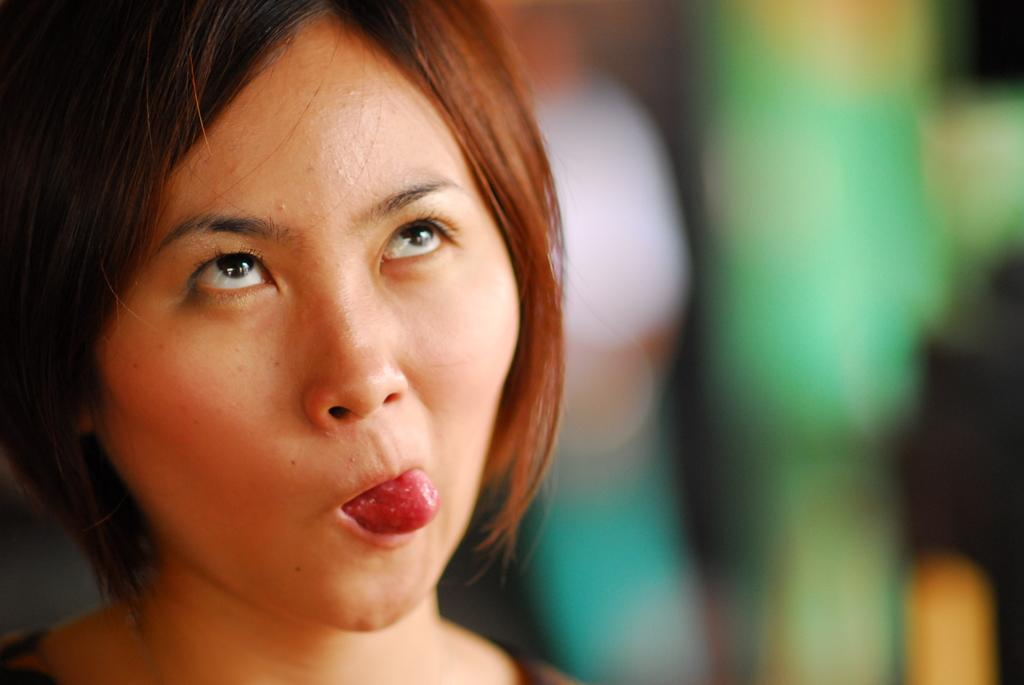Who is the main subject in the image? There is a woman in the image. What is the woman doing in the image? The woman is looking upwards. Can you describe the background of the image? The background of the image is blurred. What type of chain is hanging from the woman's neck in the image? There is no chain visible in the image; the woman is not wearing any jewelry. 